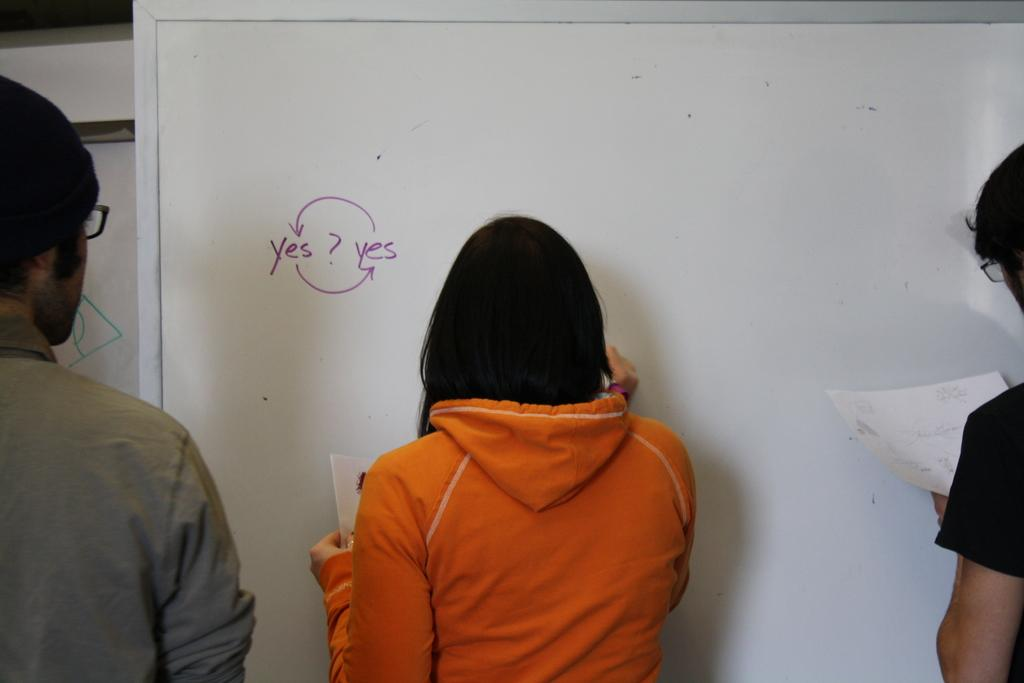How many people are in the image? There are three people in the image. What are the people doing in the image? The people are standing near a whiteboard. What is the woman doing in the image? The woman is writing on the whiteboard. What is the woman holding in her hand? The woman is holding a paper in her hand. What type of ring is the man wearing in the image? There is no ring visible on any of the people in the image. 